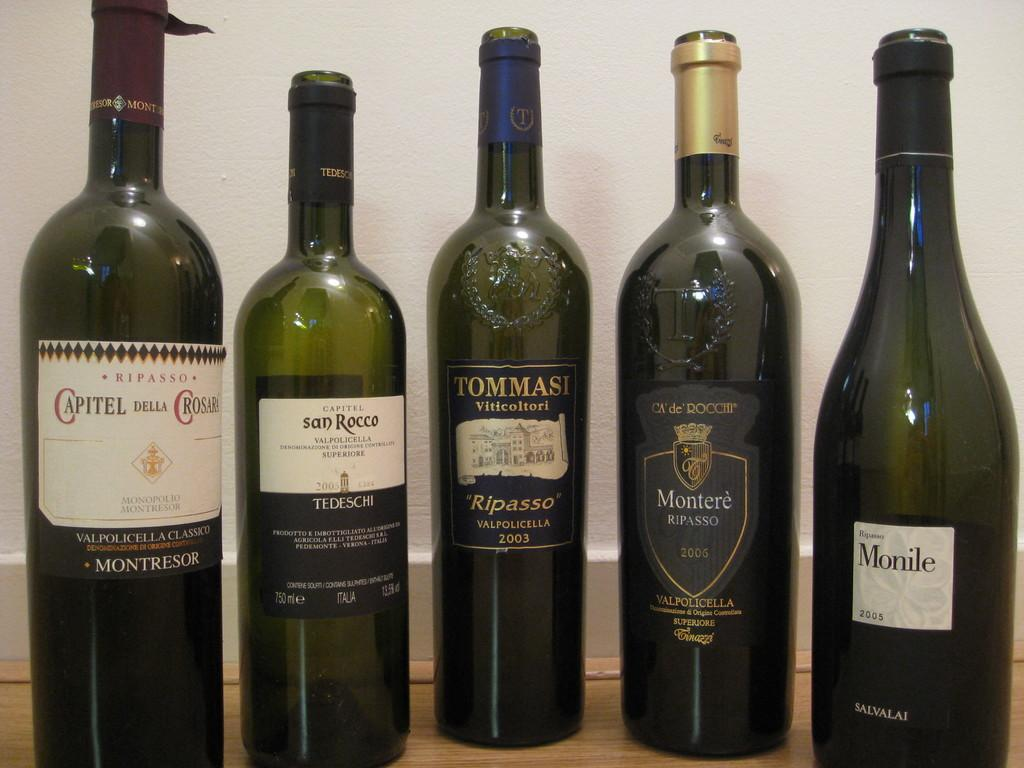<image>
Write a terse but informative summary of the picture. Green glass bottles of wine are lined up, a Tommasi wine in the center. 